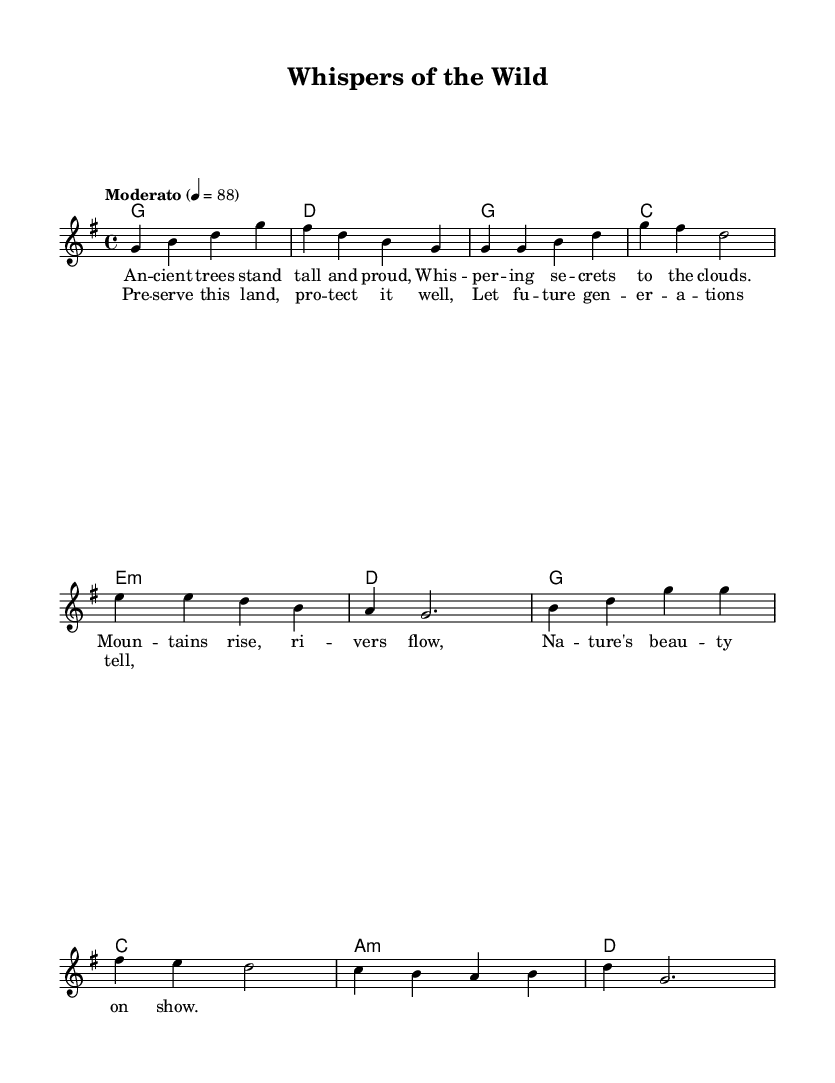What is the key signature of this music? The key signature is G major, which has one sharp (F#) indicated at the beginning of the staff.
Answer: G major What is the time signature of this music? The time signature shown at the beginning is 4/4, meaning there are four beats in each measure and the quarter note gets one beat.
Answer: 4/4 What is the tempo marking for this piece? The tempo marking is "Moderato," which signifies a moderate speed, indicated by the metronome marking of 88 beats per minute.
Answer: Moderato How many measures are in the verse? The verse consists of 4 measures as indicated by the grouping of notes in the melody section.
Answer: 4 What is the name of the song? The title at the top of the sheet music states "Whispers of the Wild."
Answer: Whispers of the Wild Which section comes after the verse in the structure of the song? The chorus follows the verse, as indicated by the transition in musical and lyrical content after the verse sections.
Answer: Chorus What theme does this song focus on? The lyrics express themes of nature, beauty, and conservation, hinting at a desire to preserve the environment for future generations.
Answer: Conservation 